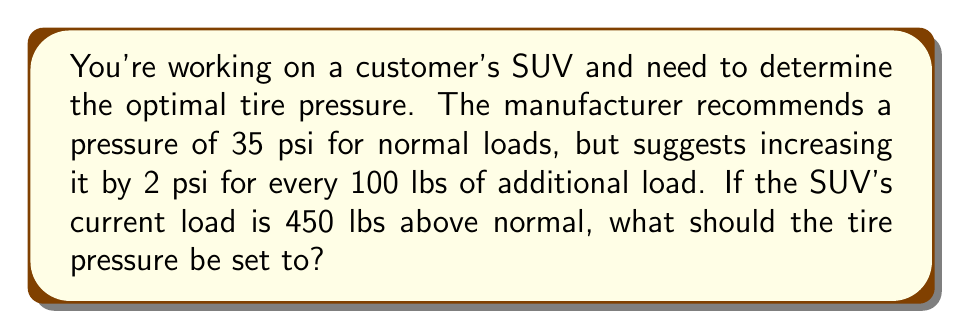Teach me how to tackle this problem. Let's approach this step-by-step:

1. Start with the base recommended pressure:
   $P_0 = 35$ psi

2. Calculate the additional pressure needed:
   - The additional load is 450 lbs
   - The pressure increases by 2 psi for every 100 lbs
   - So, we need to find how many 100 lb increments are in 450 lbs:
     $\frac{450 \text{ lbs}}{100 \text{ lbs}} = 4.5$

3. Calculate the pressure increase:
   $\Delta P = 4.5 \times 2 \text{ psi} = 9 \text{ psi}$

4. Add the pressure increase to the base pressure:
   $P_{total} = P_0 + \Delta P = 35 \text{ psi} + 9 \text{ psi} = 44 \text{ psi}$

Therefore, the optimal tire pressure for the SUV with the additional load should be 44 psi.
Answer: 44 psi 